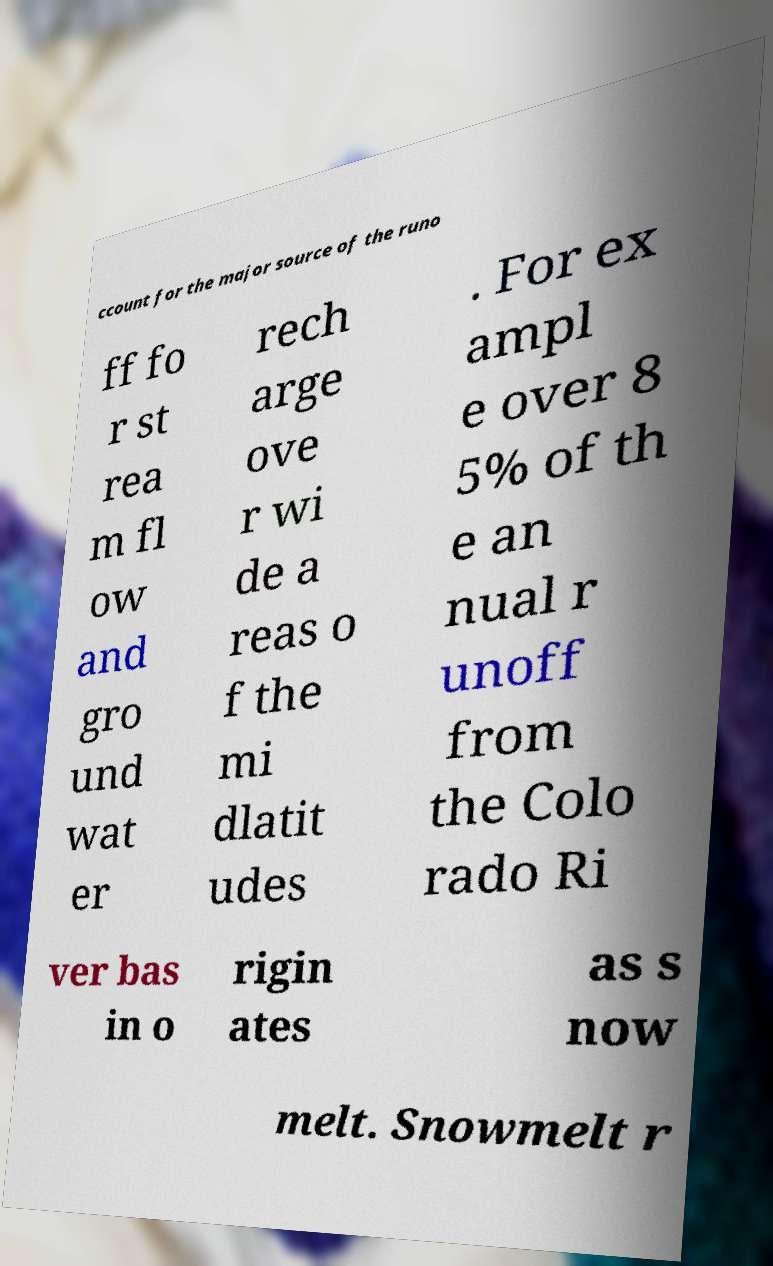Could you assist in decoding the text presented in this image and type it out clearly? ccount for the major source of the runo ff fo r st rea m fl ow and gro und wat er rech arge ove r wi de a reas o f the mi dlatit udes . For ex ampl e over 8 5% of th e an nual r unoff from the Colo rado Ri ver bas in o rigin ates as s now melt. Snowmelt r 